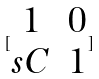Convert formula to latex. <formula><loc_0><loc_0><loc_500><loc_500>[ \begin{matrix} 1 & 0 \\ s C & 1 \end{matrix} ]</formula> 